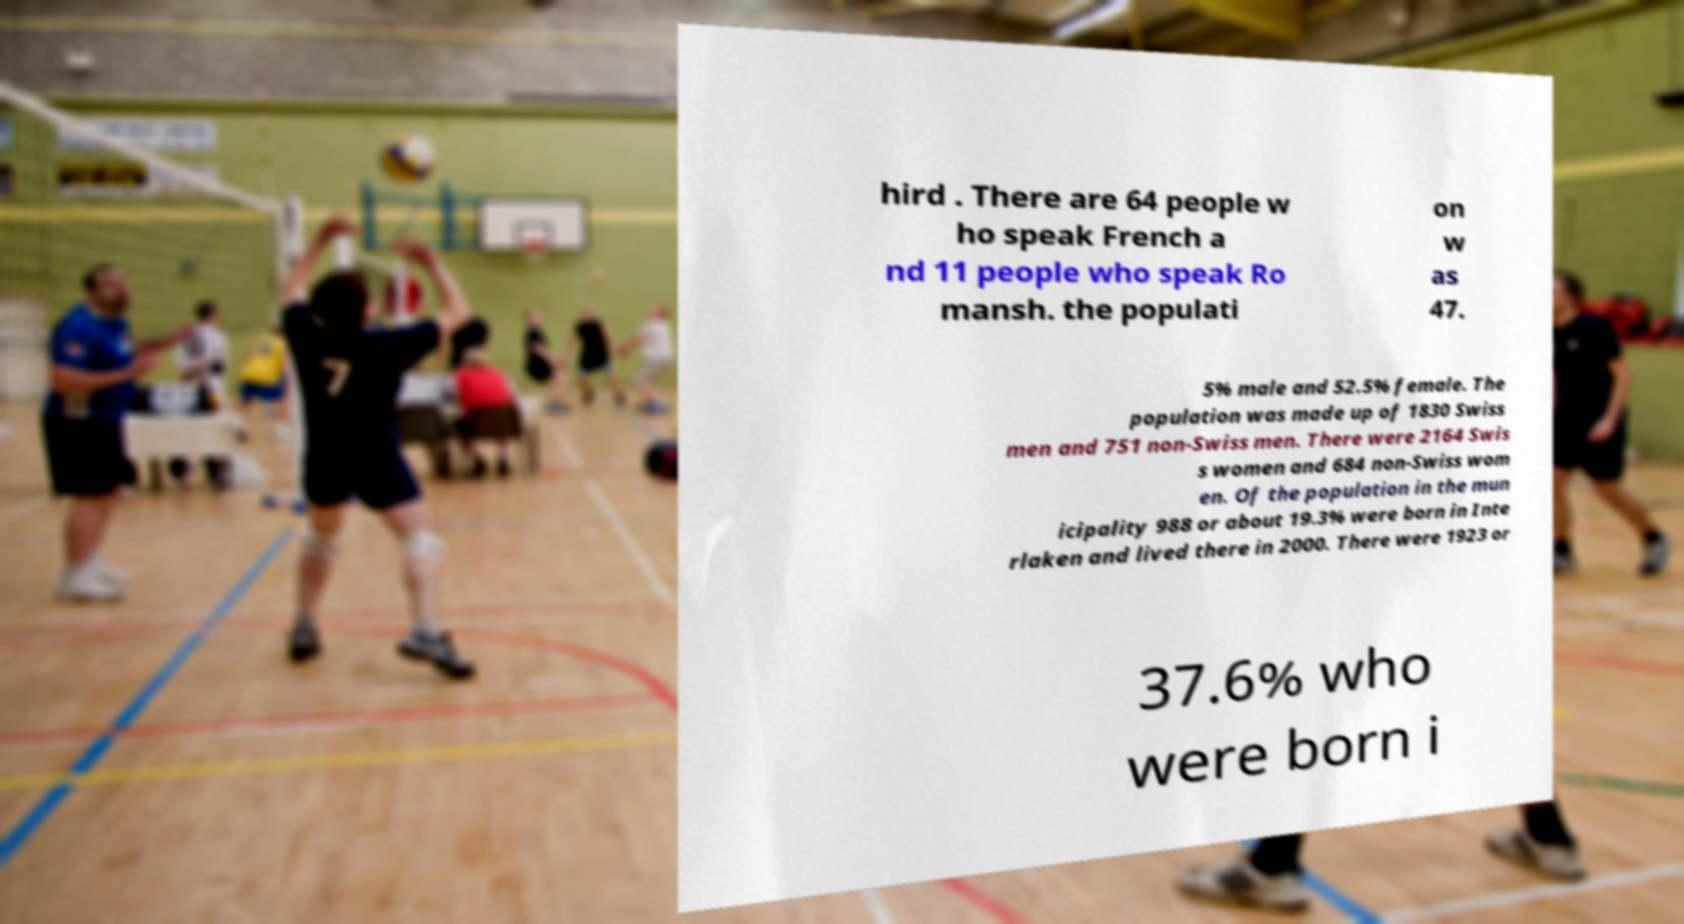For documentation purposes, I need the text within this image transcribed. Could you provide that? hird . There are 64 people w ho speak French a nd 11 people who speak Ro mansh. the populati on w as 47. 5% male and 52.5% female. The population was made up of 1830 Swiss men and 751 non-Swiss men. There were 2164 Swis s women and 684 non-Swiss wom en. Of the population in the mun icipality 988 or about 19.3% were born in Inte rlaken and lived there in 2000. There were 1923 or 37.6% who were born i 